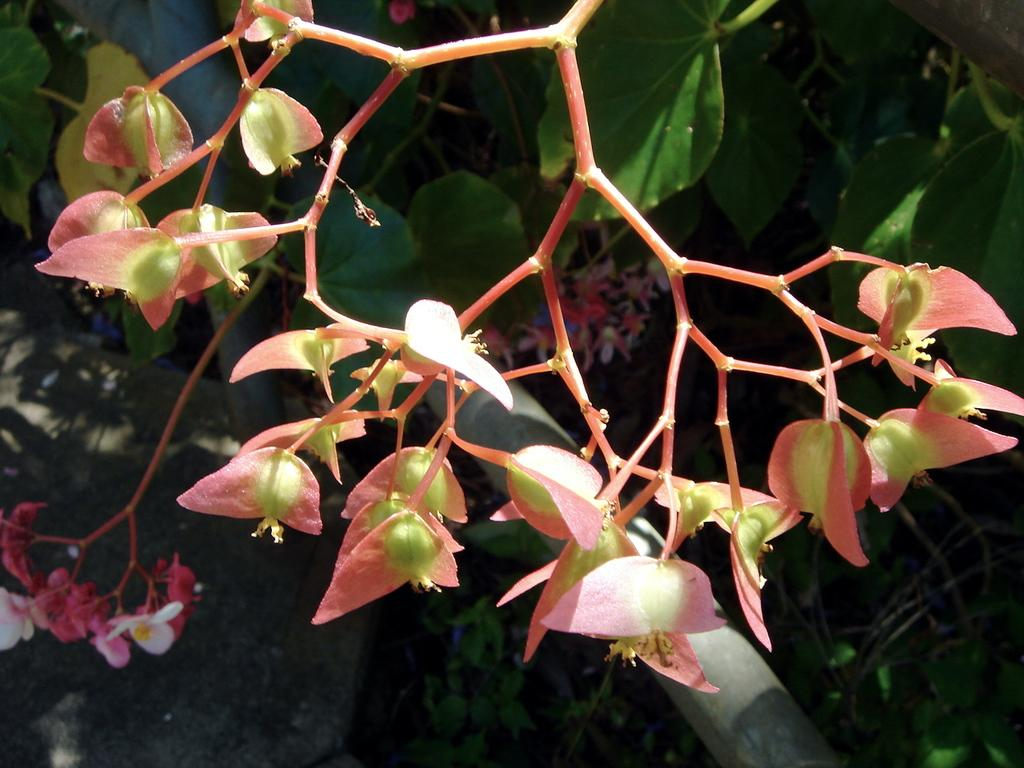What type of plant is visible in the image? There is a plant with flowers in the image. What material is the rod at the bottom of the image made of? The rod at the bottom of the image is made of metal. What can be seen at the bottom left corner of the image? The ground is visible in the bottom left corner of the image. How does the carpenter tie a knot in the image? There is no carpenter or knot present in the image. 